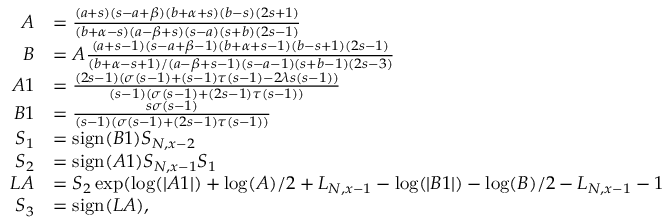Convert formula to latex. <formula><loc_0><loc_0><loc_500><loc_500>\begin{array} { r l } { A } & { = \frac { ( a + s ) ( s - a + \beta ) ( b + \alpha + s ) ( b - s ) ( 2 s + 1 ) } { ( b + \alpha - s ) ( a - \beta + s ) ( s - a ) ( s + b ) ( 2 s - 1 ) } } \\ { B } & { = A \frac { ( a + s - 1 ) ( s - a + \beta - 1 ) ( b + \alpha + s - 1 ) ( b - s + 1 ) ( 2 s - 1 ) } { ( b + \alpha - s + 1 ) / ( a - \beta + s - 1 ) ( s - a - 1 ) ( s + b - 1 ) ( 2 s - 3 ) } } \\ { A 1 } & { = \frac { ( 2 s - 1 ) ( \sigma ( s - 1 ) + ( s - 1 ) \tau ( s - 1 ) - 2 \lambda s ( s - 1 ) ) } { ( s - 1 ) ( \sigma ( s - 1 ) + ( 2 s - 1 ) \tau ( s - 1 ) ) } } \\ { B 1 } & { = \frac { s \sigma ( s - 1 ) } { ( s - 1 ) ( \sigma ( s - 1 ) + ( 2 s - 1 ) \tau ( s - 1 ) ) } } \\ { S _ { 1 } } & { = s i g n ( B 1 ) S _ { N , x - 2 } } \\ { S _ { 2 } } & { = s i g n ( A 1 ) S _ { N , x - 1 } S _ { 1 } } \\ { L A } & { = S _ { 2 } \exp ( \log ( | A 1 | ) + \log ( A ) / 2 + L _ { N , x - 1 } - \log ( | B 1 | ) - \log ( B ) / 2 - L _ { N , x - 1 } - 1 } \\ { S _ { 3 } } & { = s i g n ( L A ) , } \end{array}</formula> 